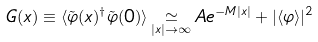Convert formula to latex. <formula><loc_0><loc_0><loc_500><loc_500>G ( x ) \equiv \langle \tilde { \varphi } ( x ) ^ { \dagger } \tilde { \varphi } ( 0 ) \rangle \mathop \simeq _ { | x | \to \infty } A e ^ { - M | x | } + | \langle \varphi \rangle | ^ { 2 }</formula> 